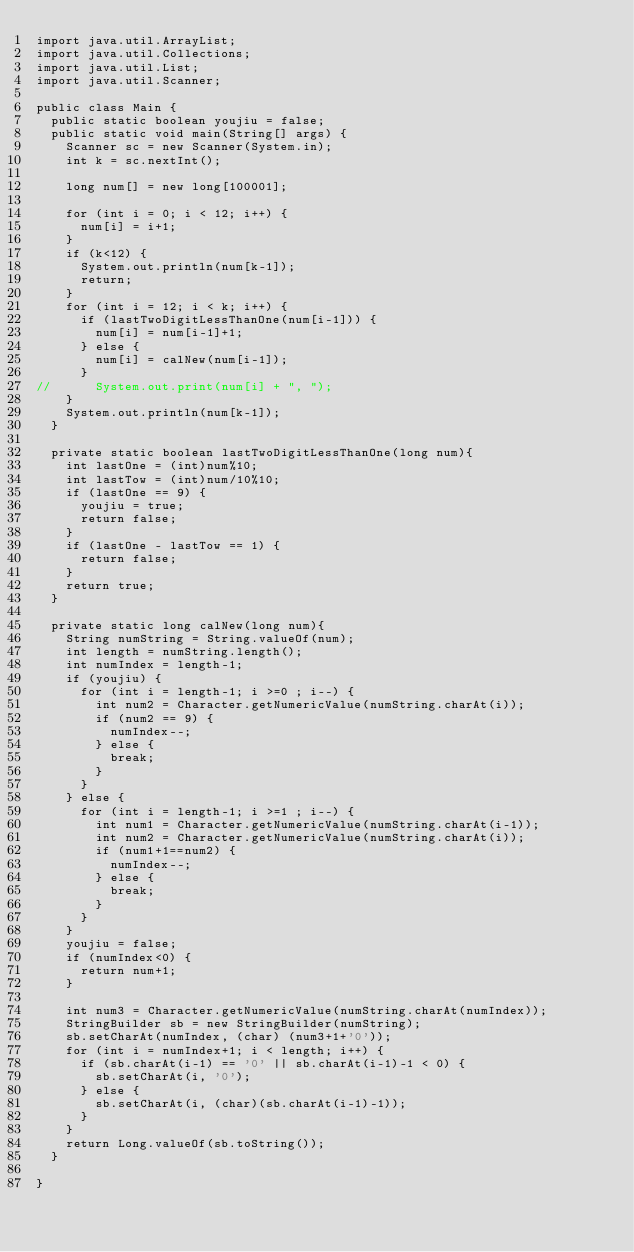Convert code to text. <code><loc_0><loc_0><loc_500><loc_500><_Java_>import java.util.ArrayList;
import java.util.Collections;
import java.util.List;
import java.util.Scanner;

public class Main {
	public static boolean youjiu = false;
	public static void main(String[] args) {
		Scanner sc = new Scanner(System.in);
		int k = sc.nextInt();

		long num[] = new long[100001];

		for (int i = 0; i < 12; i++) {
			num[i] = i+1;
		}
		if (k<12) {
			System.out.println(num[k-1]);
			return;
		}
		for (int i = 12; i < k; i++) {
			if (lastTwoDigitLessThanOne(num[i-1])) {
				num[i] = num[i-1]+1;
			} else {
				num[i] = calNew(num[i-1]);
			}
//			System.out.print(num[i] + ", ");
		}
		System.out.println(num[k-1]);
	}

	private static boolean lastTwoDigitLessThanOne(long num){
		int lastOne = (int)num%10;
		int lastTow = (int)num/10%10;
		if (lastOne == 9) {
			youjiu = true;
			return false;
		}
		if (lastOne - lastTow == 1) {
			return false;
		}
		return true;
	}

	private static long calNew(long num){
		String numString = String.valueOf(num);
		int length = numString.length();
		int numIndex = length-1;
		if (youjiu) {
			for (int i = length-1; i >=0 ; i--) {
				int num2 = Character.getNumericValue(numString.charAt(i));
				if (num2 == 9) {
					numIndex--;
				} else {
					break;
				}
			}
		} else {
			for (int i = length-1; i >=1 ; i--) {
				int num1 = Character.getNumericValue(numString.charAt(i-1));
				int num2 = Character.getNumericValue(numString.charAt(i));
				if (num1+1==num2) {
					numIndex--;
				} else {
					break;
				}
			}
		}
		youjiu = false;
		if (numIndex<0) {
			return num+1;
		}

		int num3 = Character.getNumericValue(numString.charAt(numIndex));
		StringBuilder sb = new StringBuilder(numString);
		sb.setCharAt(numIndex, (char) (num3+1+'0'));
		for (int i = numIndex+1; i < length; i++) {
			if (sb.charAt(i-1) == '0' || sb.charAt(i-1)-1 < 0) {
				sb.setCharAt(i, '0');
			} else {
				sb.setCharAt(i, (char)(sb.charAt(i-1)-1));
			}
		}
		return Long.valueOf(sb.toString());
	}

}
</code> 